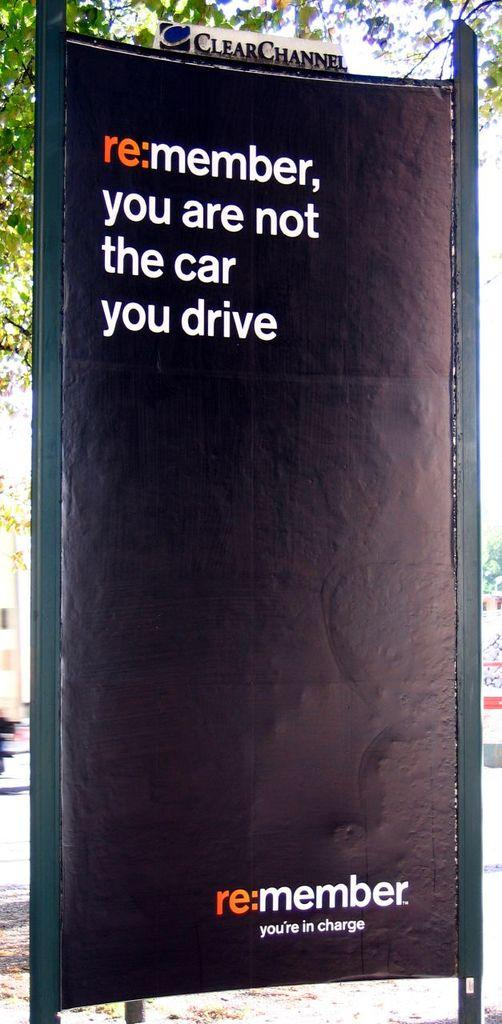What is the main object in the center of the image? There is a board in the center of the image. What can be seen in the background of the image? There is a tree in the background of the image. How many ducks are swimming in the water near the board in the image? There are no ducks or water present in the image; it only features a board and a tree in the background. 